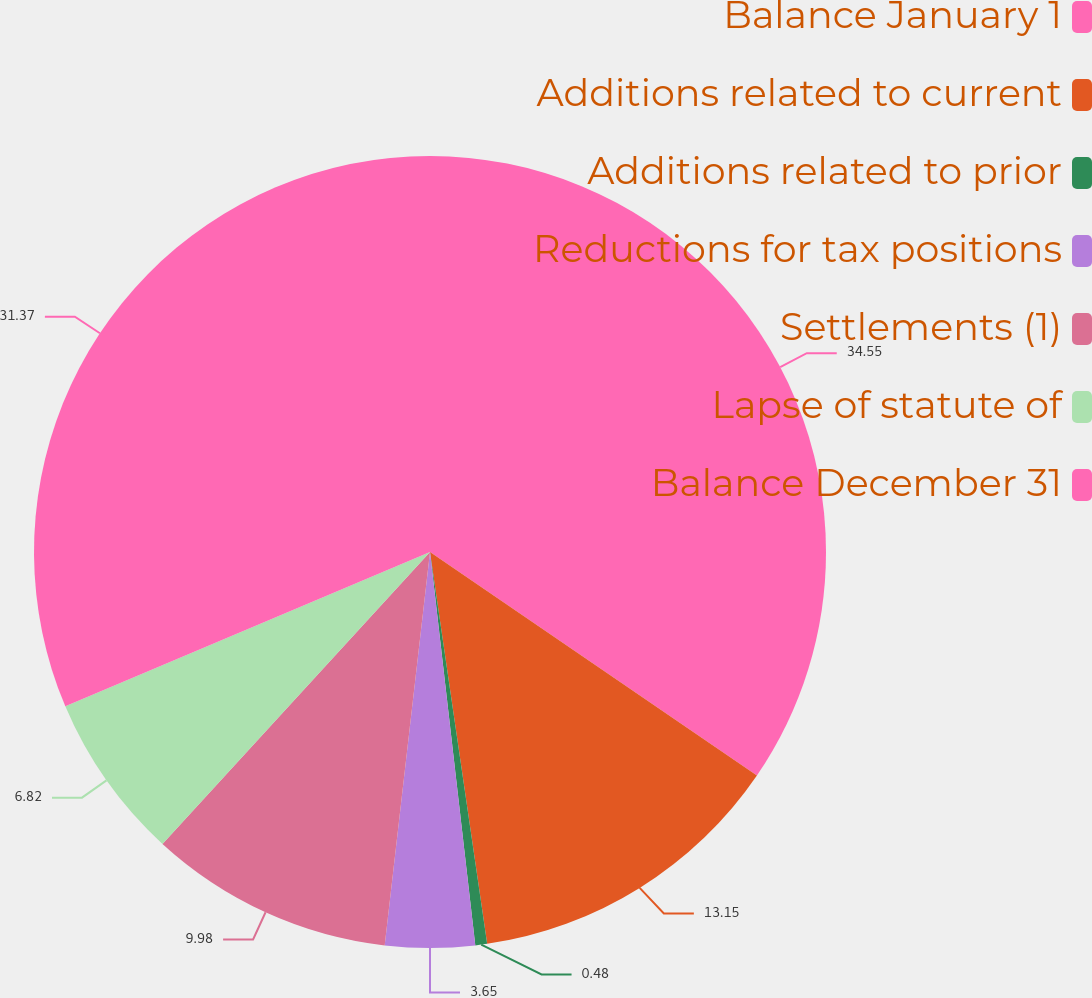<chart> <loc_0><loc_0><loc_500><loc_500><pie_chart><fcel>Balance January 1<fcel>Additions related to current<fcel>Additions related to prior<fcel>Reductions for tax positions<fcel>Settlements (1)<fcel>Lapse of statute of<fcel>Balance December 31<nl><fcel>34.54%<fcel>13.15%<fcel>0.48%<fcel>3.65%<fcel>9.98%<fcel>6.82%<fcel>31.37%<nl></chart> 